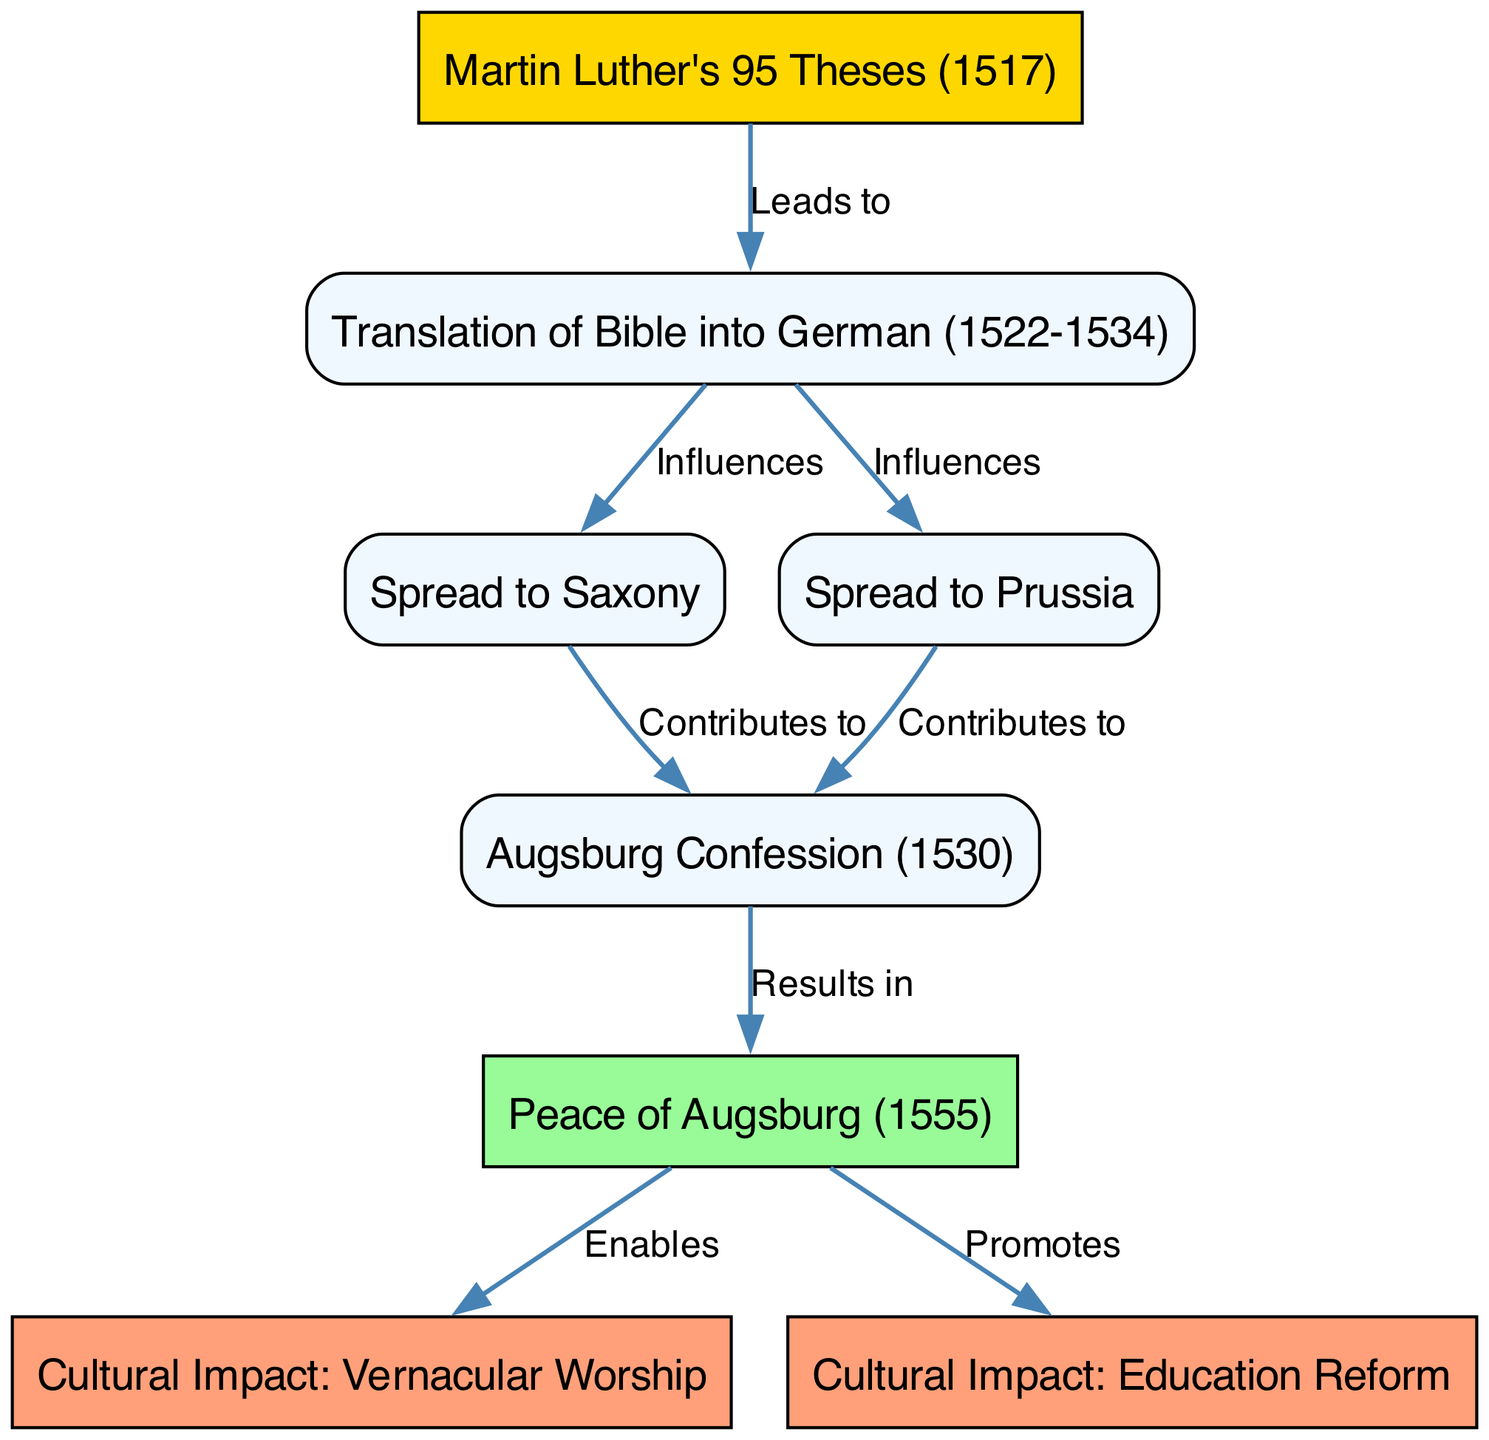What is the starting point of the flow chart? The starting point of the flow chart is represented by the node labeled "Martin Luther's 95 Theses (1517)". This node initiates the process and connects to the subsequent nodes indicating the flow of influence that follows from this event.
Answer: Martin Luther's 95 Theses (1517) How many cultural impact nodes are present in the diagram? The diagram contains two cultural impact nodes, which are "Cultural Impact: Vernacular Worship" and "Cultural Impact: Education Reform". This can be verified by counting the nodes labeled with "Cultural Impact" in the diagram.
Answer: 2 What event directly results from the Augsburg Confession? The event that directly results from the Augsburg Confession is the "Peace of Augsburg (1555)", as indicated by the directed edge labeled "Results in", connecting the two nodes.
Answer: Peace of Augsburg (1555) Which node does the "Translation of Bible into German" influence first? The "Translation of Bible into German" influences two nodes next, which are the nodes for "Spread to Saxony" and "Spread to Prussia". Thus, it influences both nodes concurrently and the first interaction upon influence cannot be distinctly determined.
Answer: Spread to Saxony and Spread to Prussia How does the "Peace of Augsburg" impact the cultural aspects? The "Peace of Augsburg" enables "Cultural Impact: Vernacular Worship" and promotes "Cultural Impact: Education Reform", showing it affects both cultural aspects as it connects to these two nodes through labeled edges indicating enablement and promotion.
Answer: Enables and promotes cultural impacts 